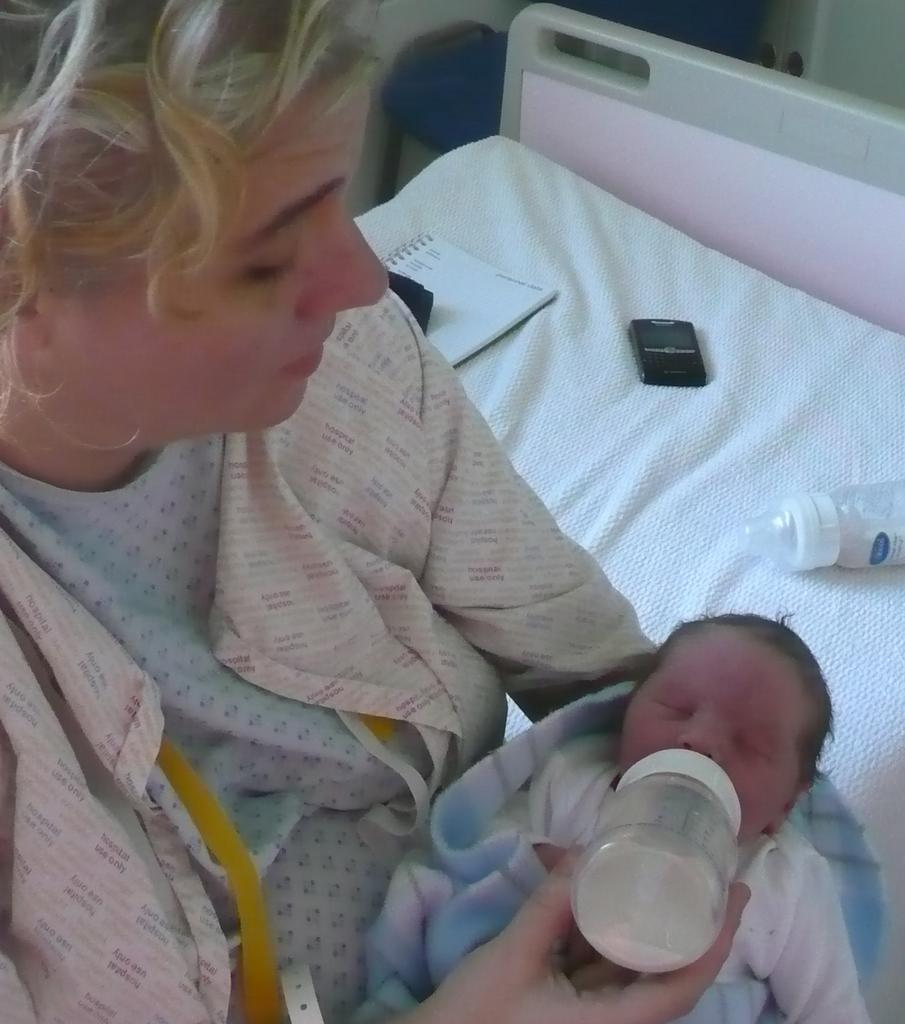Who is the main subject in the image? There is a woman in the image. What is the woman doing in the image? The woman is sitting and feeding milk to a baby. What else can be seen on the bed in the image? There is a book, a mobile phone, and a milk bottle on the bed. What type of cloud can be seen in the image? There is no cloud present in the image. What is the woman's occupation, as seen in the image? The image does not provide information about the woman's occupation. Where is the faucet located in the image? There is no faucet present in the image. 